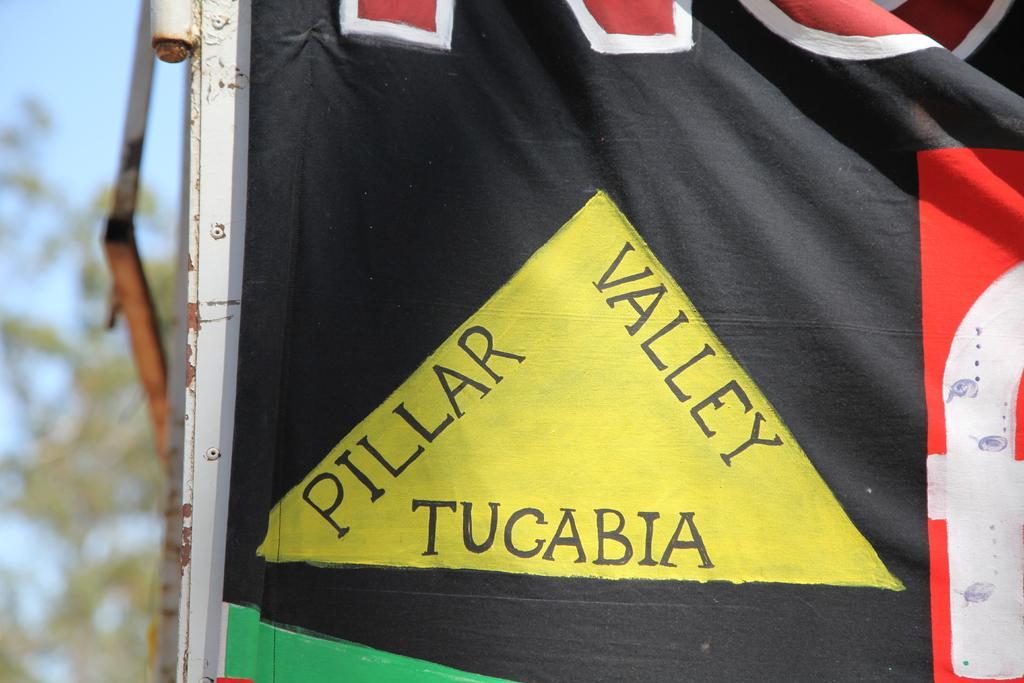Please provide a concise description of this image. In this image, we can see a cloth contains some text. In the background, image is blurred. 